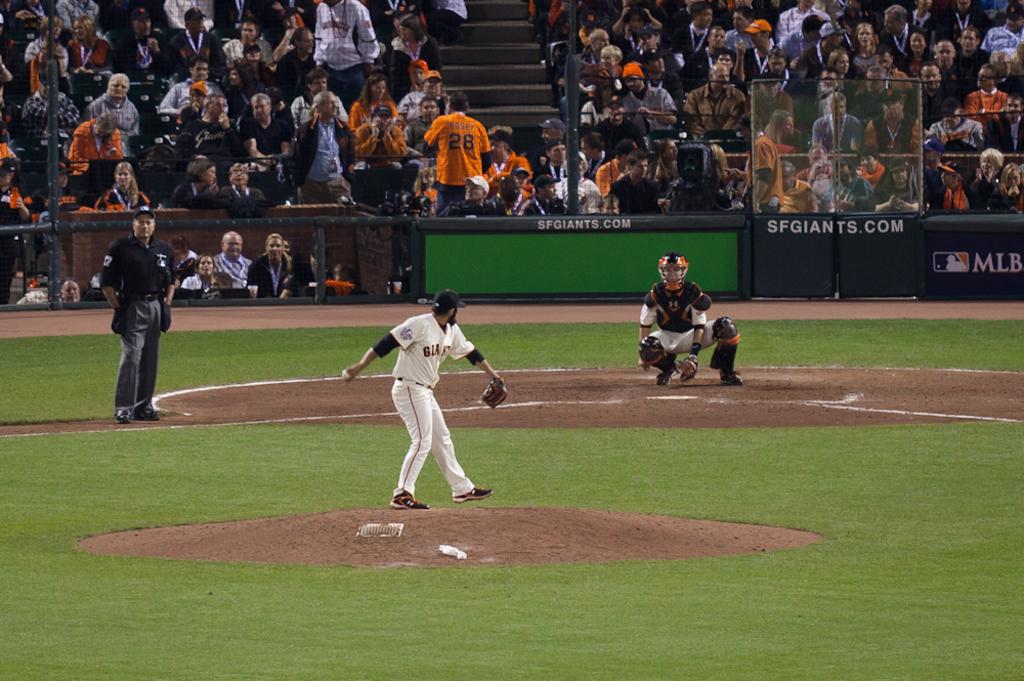<image>
Write a terse but informative summary of the picture. a baseball player about to throw a ball in a field with signs saying MLB and SF Giants 